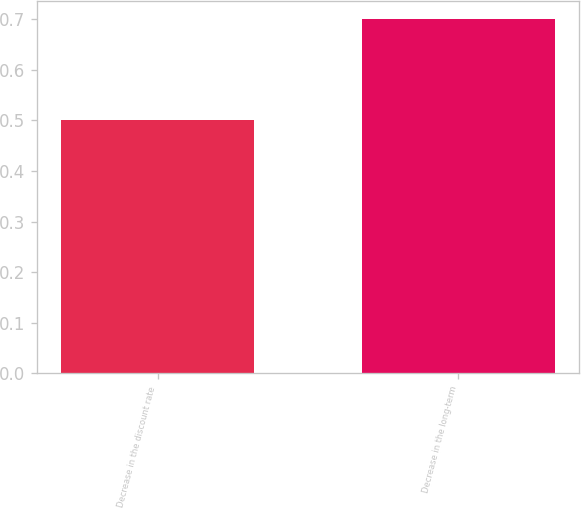Convert chart to OTSL. <chart><loc_0><loc_0><loc_500><loc_500><bar_chart><fcel>Decrease in the discount rate<fcel>Decrease in the long-term<nl><fcel>0.5<fcel>0.7<nl></chart> 